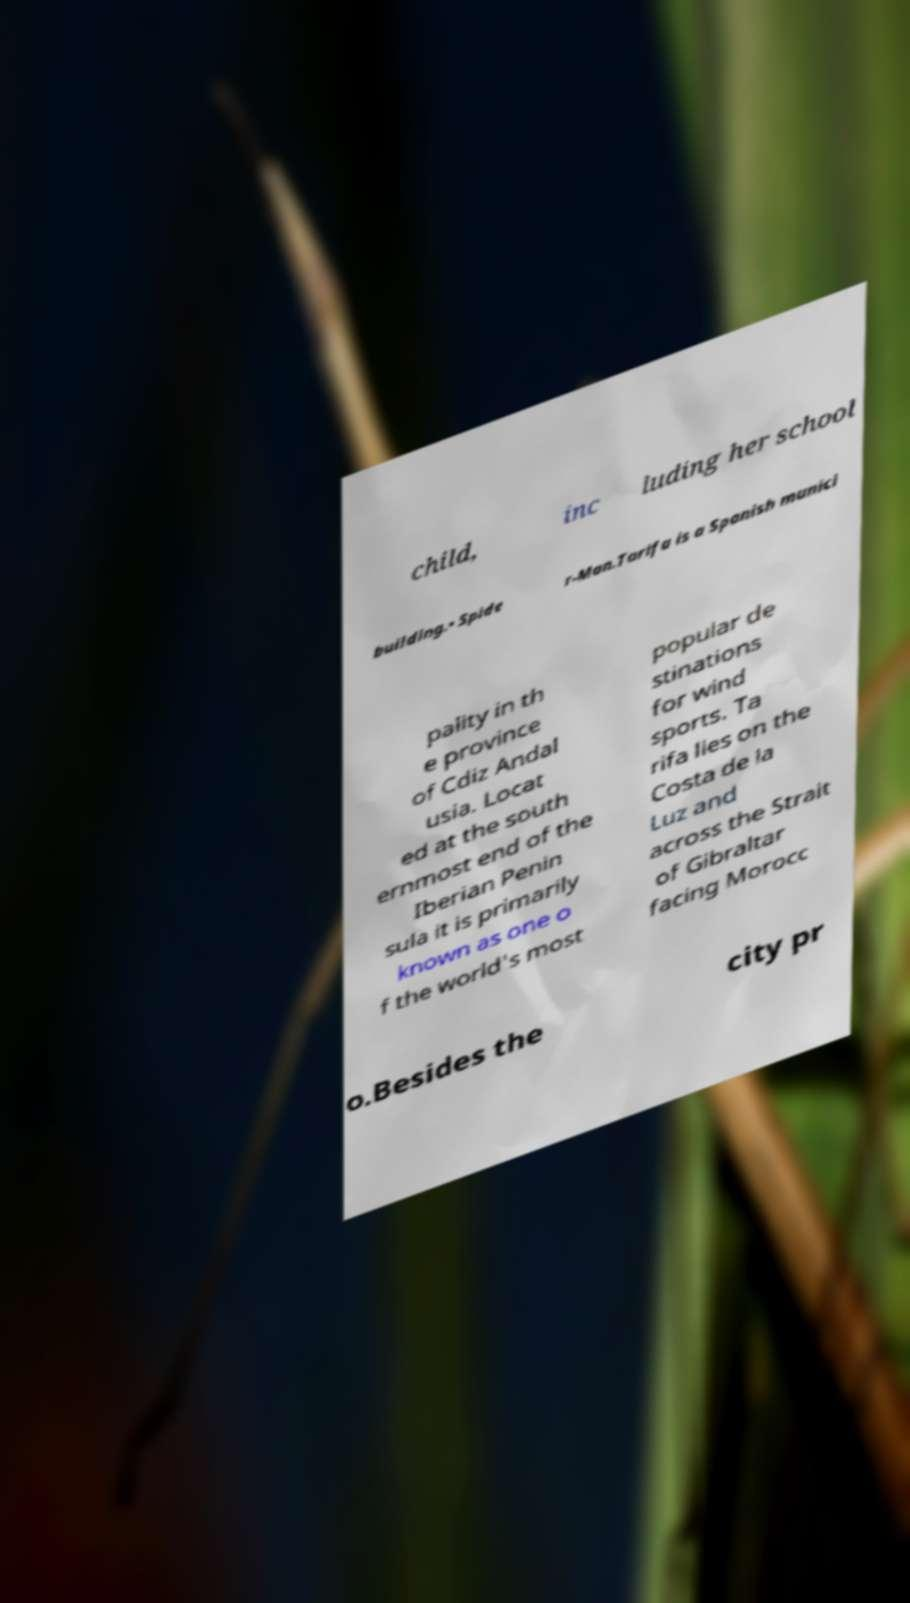For documentation purposes, I need the text within this image transcribed. Could you provide that? child, inc luding her school building.• Spide r-Man.Tarifa is a Spanish munici pality in th e province of Cdiz Andal usia. Locat ed at the south ernmost end of the Iberian Penin sula it is primarily known as one o f the world's most popular de stinations for wind sports. Ta rifa lies on the Costa de la Luz and across the Strait of Gibraltar facing Morocc o.Besides the city pr 